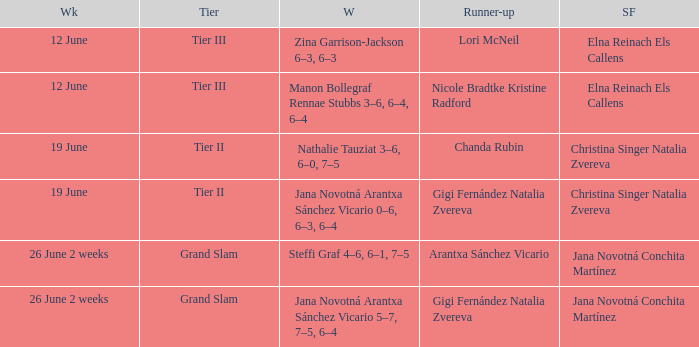When the runner-up is listed as Gigi Fernández Natalia Zvereva and the week is 26 June 2 weeks, who are the semi finalists? Jana Novotná Conchita Martínez. 